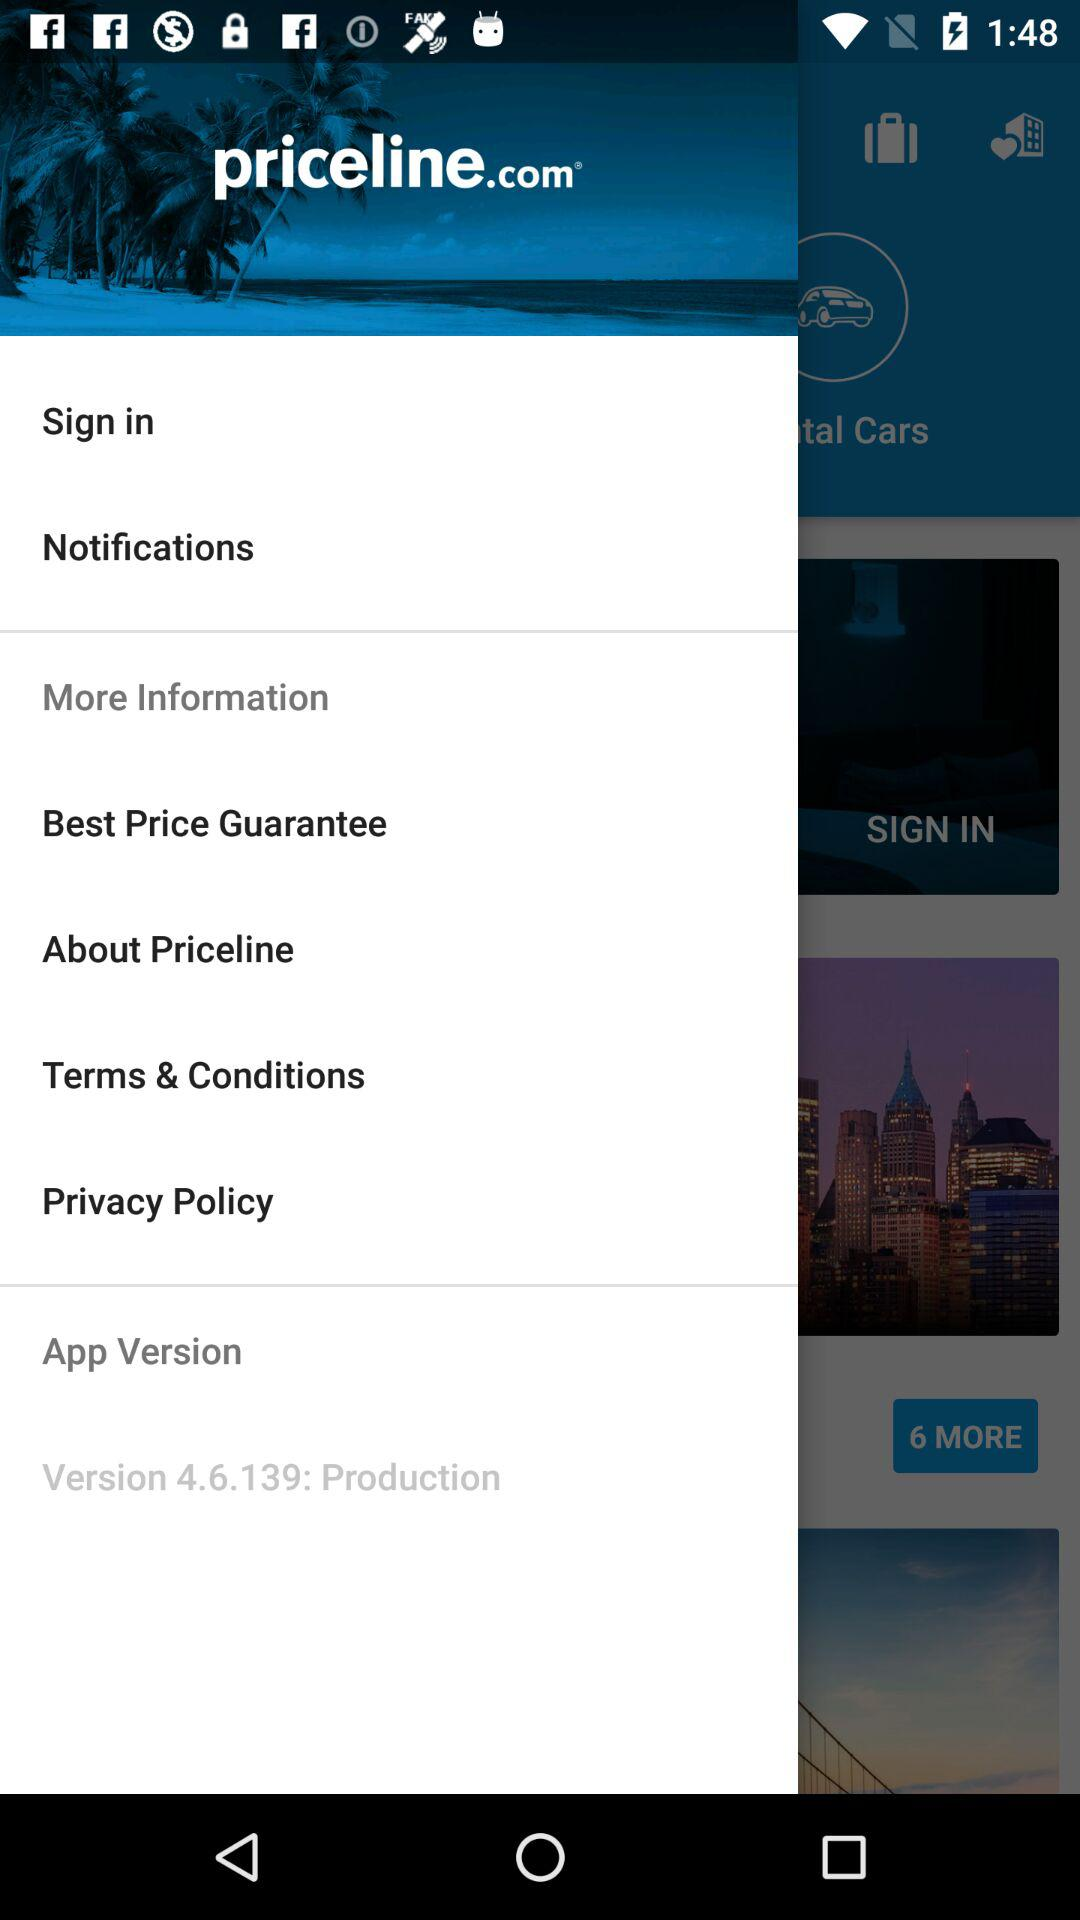What is the application version? The application version is 4.6.139. 